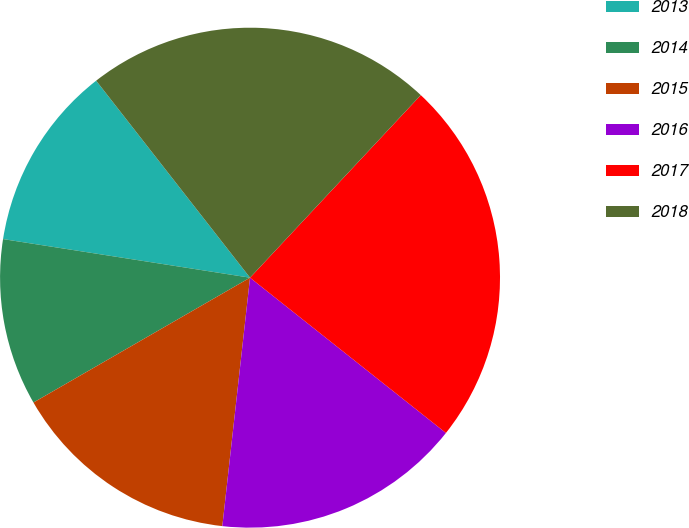Convert chart to OTSL. <chart><loc_0><loc_0><loc_500><loc_500><pie_chart><fcel>2013<fcel>2014<fcel>2015<fcel>2016<fcel>2017<fcel>2018<nl><fcel>11.98%<fcel>10.79%<fcel>14.91%<fcel>16.1%<fcel>23.7%<fcel>22.52%<nl></chart> 